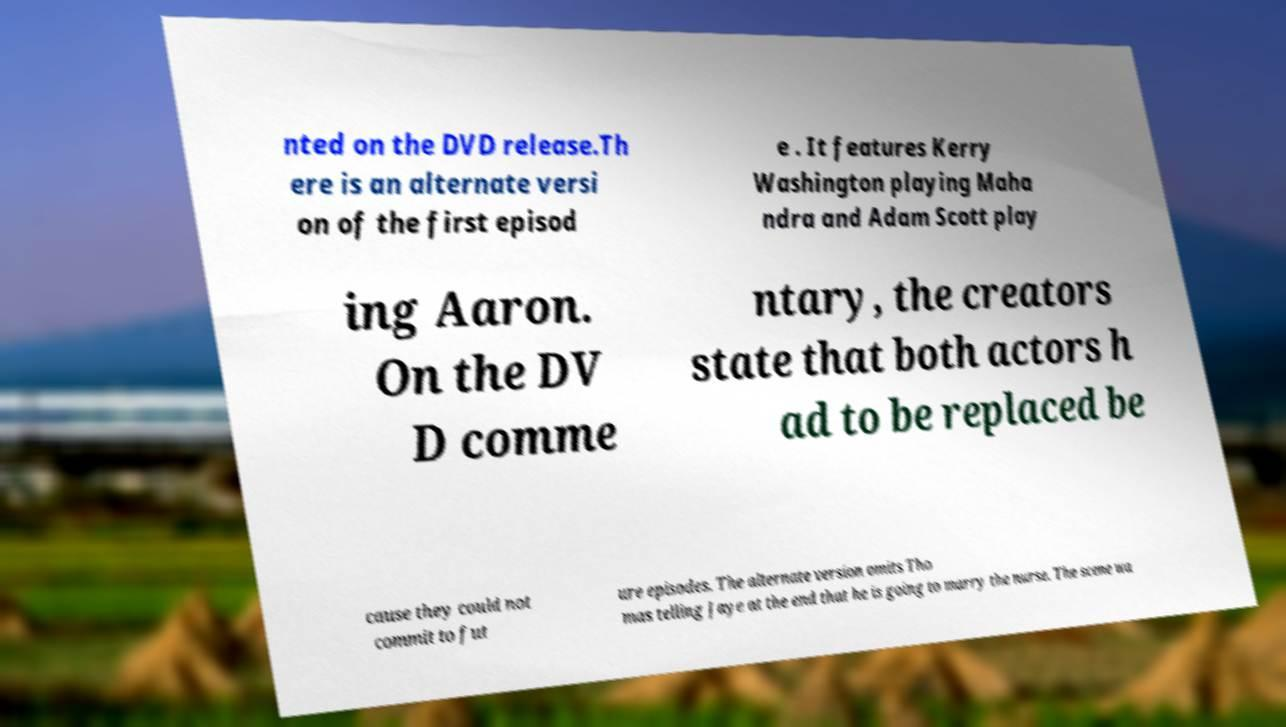Please read and relay the text visible in this image. What does it say? nted on the DVD release.Th ere is an alternate versi on of the first episod e . It features Kerry Washington playing Maha ndra and Adam Scott play ing Aaron. On the DV D comme ntary, the creators state that both actors h ad to be replaced be cause they could not commit to fut ure episodes. The alternate version omits Tho mas telling Jaye at the end that he is going to marry the nurse. The scene wa 